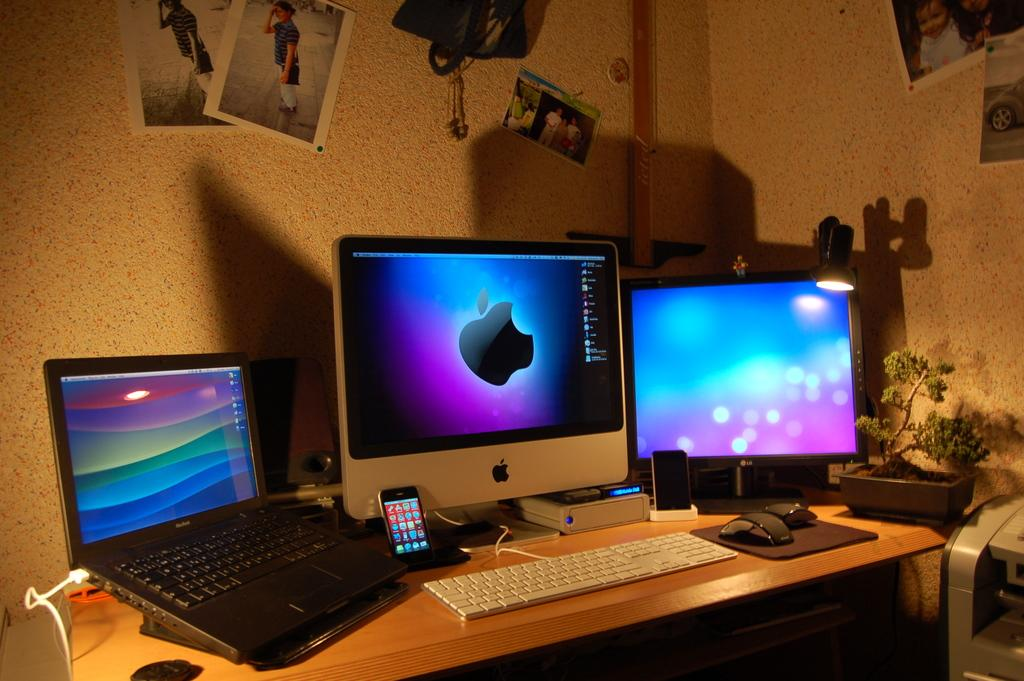What type of space is depicted in the image? The image is of a room. What furniture is present in the room? There is a table in the room. What electronic devices can be seen on the table? A laptop, a mobile phone, and 2 PCs are on the table. What accessories are on the table for use with the electronic devices? A keyboard and a mouse are on the table. What type of plant is in the room? There is a water plant in the room. What decorations are on the walls? There are photographs attached to the wall and a poster on the wall. What type of kitten can be seen playing with the cloud in the image? There is no kitten or cloud present in the image; the image depicts a room with electronic devices and a water plant. What is the view like from the window in the image? There is no window present in the image, so it is not possible to determine the view. 